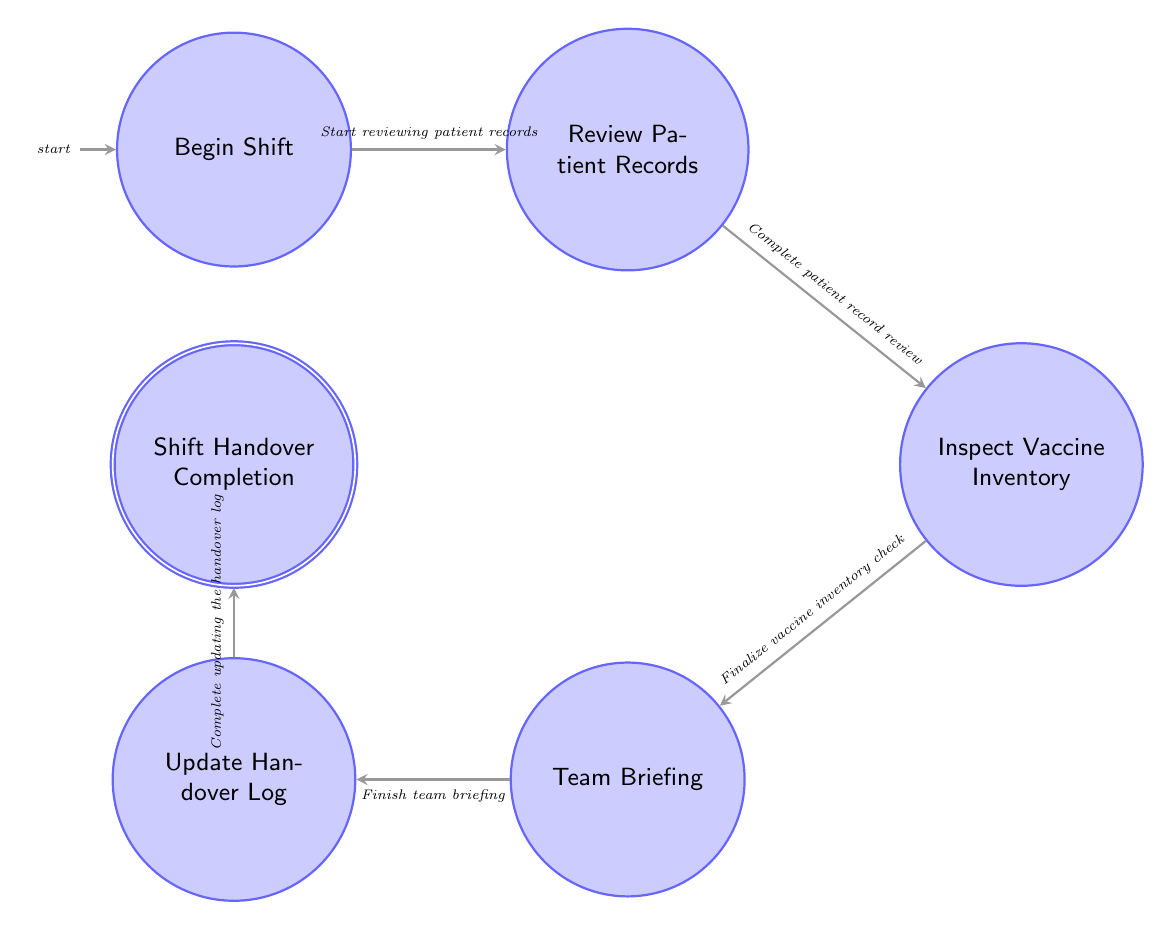What is the first state in the shift handover process? The first state listed in the diagram is "Begin Shift," indicating it is the starting point of the process.
Answer: Begin Shift How many states are present in the diagram? There are six states shown in the diagram: Begin Shift, Review Patient Records, Inspect Vaccine Inventory, Team Briefing, Update Handover Log, and Shift Handover Completion.
Answer: 6 What action transitions from "Review Patient Records" to "Inspect Vaccine Inventory"? The action that leads from "Review Patient Records" to "Inspect Vaccine Inventory" is "Complete patient record review and move to vaccine inventory inspection".
Answer: Complete patient record review What do you do after inspecting the vaccine inventory? After inspecting the vaccine inventory, the next step is to conduct the team briefing, according to the flow of the diagram.
Answer: Conduct team briefing Which state must be completed before updating the handover log? The state that must be completed before updating the handover log is "Team Briefing," as the diagram shows a direct transition from Team Briefing to Update Handover Log.
Answer: Team Briefing What is the final state of the shift handover process? The final state in the shift handover process is "Shift Handover Completion," indicating the conclusion of the process.
Answer: Shift Handover Completion Which action occurs immediately before confirming shift handover? The action that occurs immediately before confirming the shift handover is "Complete updating the handover log."
Answer: Complete updating the handover log How many transitions are there between the states? There are five transitions connecting the six states in the diagram.
Answer: 5 What is the significant focus during the "Review Patient Records" state? The significant focus during the "Review Patient Records" state is reviewing records of patients who have received or are due for vaccination.
Answer: Vaccination records 